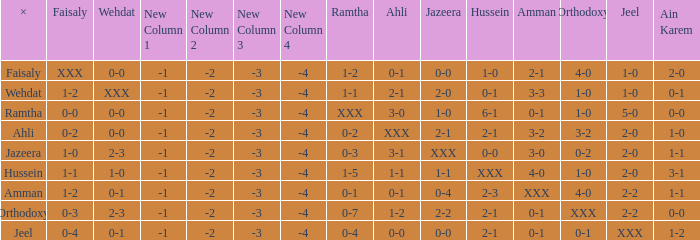What is orthodoxy when x is wehdat? 1-0. 